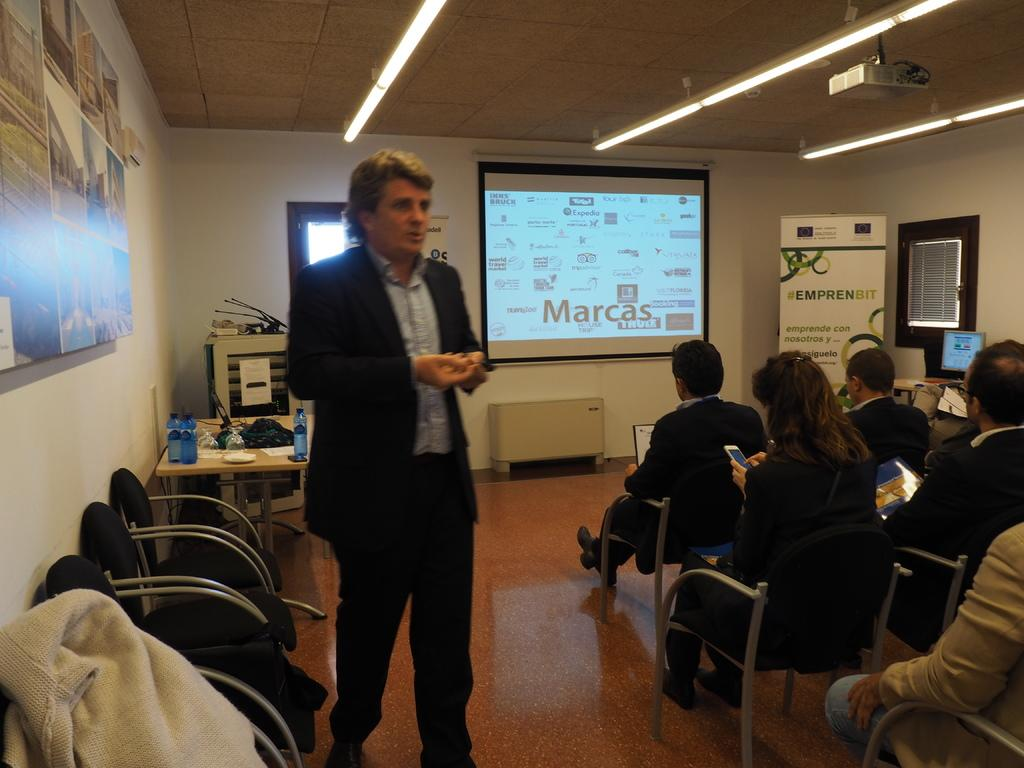What is the man in the image doing? The man is standing and speaking. What are the people in the image doing? The people are sitting on chairs. Can you describe any light source in the image? Yes, there is a light in the image. What is being projected in the image? There is a projected image in the image. Is the existence of the bean in the image confirmed? There is no mention of a bean in the provided facts, so it cannot be confirmed that a bean is present in the image. 